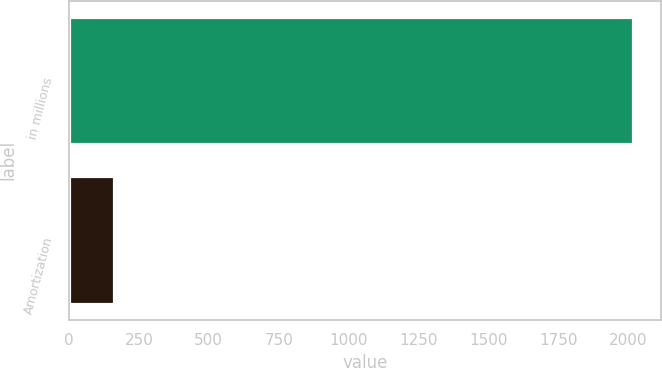Convert chart. <chart><loc_0><loc_0><loc_500><loc_500><bar_chart><fcel>in millions<fcel>Amortization<nl><fcel>2016<fcel>162<nl></chart> 